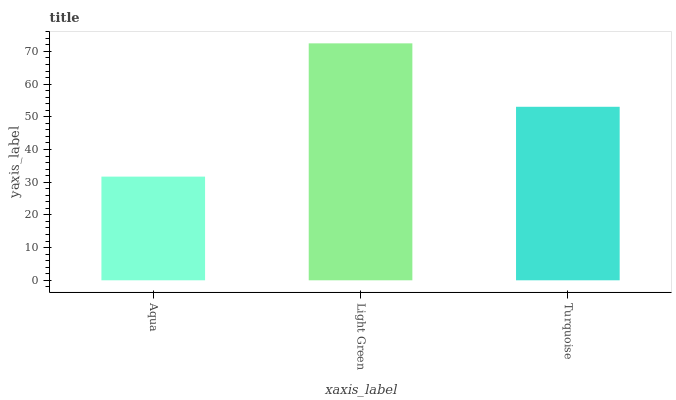Is Aqua the minimum?
Answer yes or no. Yes. Is Light Green the maximum?
Answer yes or no. Yes. Is Turquoise the minimum?
Answer yes or no. No. Is Turquoise the maximum?
Answer yes or no. No. Is Light Green greater than Turquoise?
Answer yes or no. Yes. Is Turquoise less than Light Green?
Answer yes or no. Yes. Is Turquoise greater than Light Green?
Answer yes or no. No. Is Light Green less than Turquoise?
Answer yes or no. No. Is Turquoise the high median?
Answer yes or no. Yes. Is Turquoise the low median?
Answer yes or no. Yes. Is Aqua the high median?
Answer yes or no. No. Is Aqua the low median?
Answer yes or no. No. 